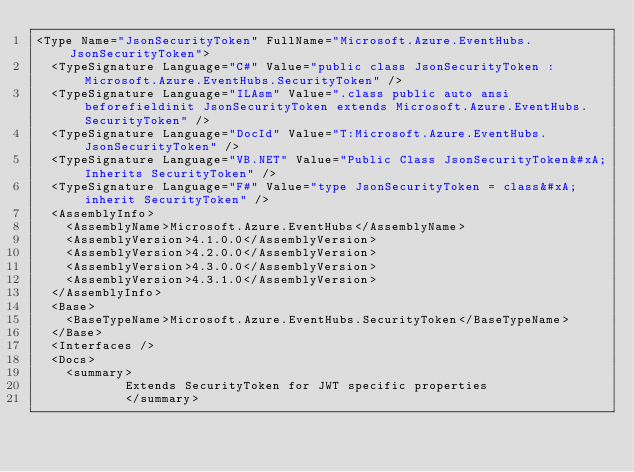Convert code to text. <code><loc_0><loc_0><loc_500><loc_500><_XML_><Type Name="JsonSecurityToken" FullName="Microsoft.Azure.EventHubs.JsonSecurityToken">
  <TypeSignature Language="C#" Value="public class JsonSecurityToken : Microsoft.Azure.EventHubs.SecurityToken" />
  <TypeSignature Language="ILAsm" Value=".class public auto ansi beforefieldinit JsonSecurityToken extends Microsoft.Azure.EventHubs.SecurityToken" />
  <TypeSignature Language="DocId" Value="T:Microsoft.Azure.EventHubs.JsonSecurityToken" />
  <TypeSignature Language="VB.NET" Value="Public Class JsonSecurityToken&#xA;Inherits SecurityToken" />
  <TypeSignature Language="F#" Value="type JsonSecurityToken = class&#xA;    inherit SecurityToken" />
  <AssemblyInfo>
    <AssemblyName>Microsoft.Azure.EventHubs</AssemblyName>
    <AssemblyVersion>4.1.0.0</AssemblyVersion>
    <AssemblyVersion>4.2.0.0</AssemblyVersion>
    <AssemblyVersion>4.3.0.0</AssemblyVersion>
    <AssemblyVersion>4.3.1.0</AssemblyVersion>
  </AssemblyInfo>
  <Base>
    <BaseTypeName>Microsoft.Azure.EventHubs.SecurityToken</BaseTypeName>
  </Base>
  <Interfaces />
  <Docs>
    <summary>
            Extends SecurityToken for JWT specific properties
            </summary></code> 